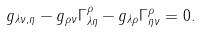<formula> <loc_0><loc_0><loc_500><loc_500>g _ { \lambda \nu , \eta } - g _ { \rho \nu } \Gamma ^ { \rho } _ { \lambda \eta } - g _ { \lambda \rho } \Gamma ^ { \rho } _ { \eta \nu } = 0 .</formula> 